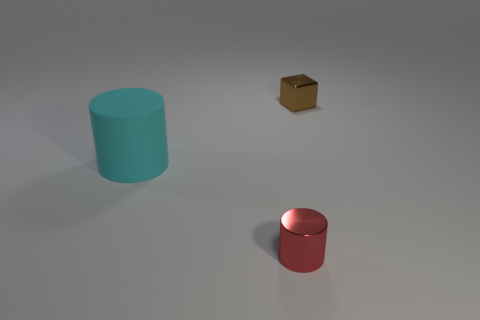Subtract all blocks. How many objects are left? 2 Subtract 1 blocks. How many blocks are left? 0 Subtract all yellow cylinders. Subtract all cyan blocks. How many cylinders are left? 2 Subtract all purple cubes. How many red cylinders are left? 1 Subtract all red shiny cylinders. Subtract all small brown objects. How many objects are left? 1 Add 2 brown metal objects. How many brown metal objects are left? 3 Add 3 tiny red cylinders. How many tiny red cylinders exist? 4 Add 2 red cylinders. How many objects exist? 5 Subtract 1 cyan cylinders. How many objects are left? 2 